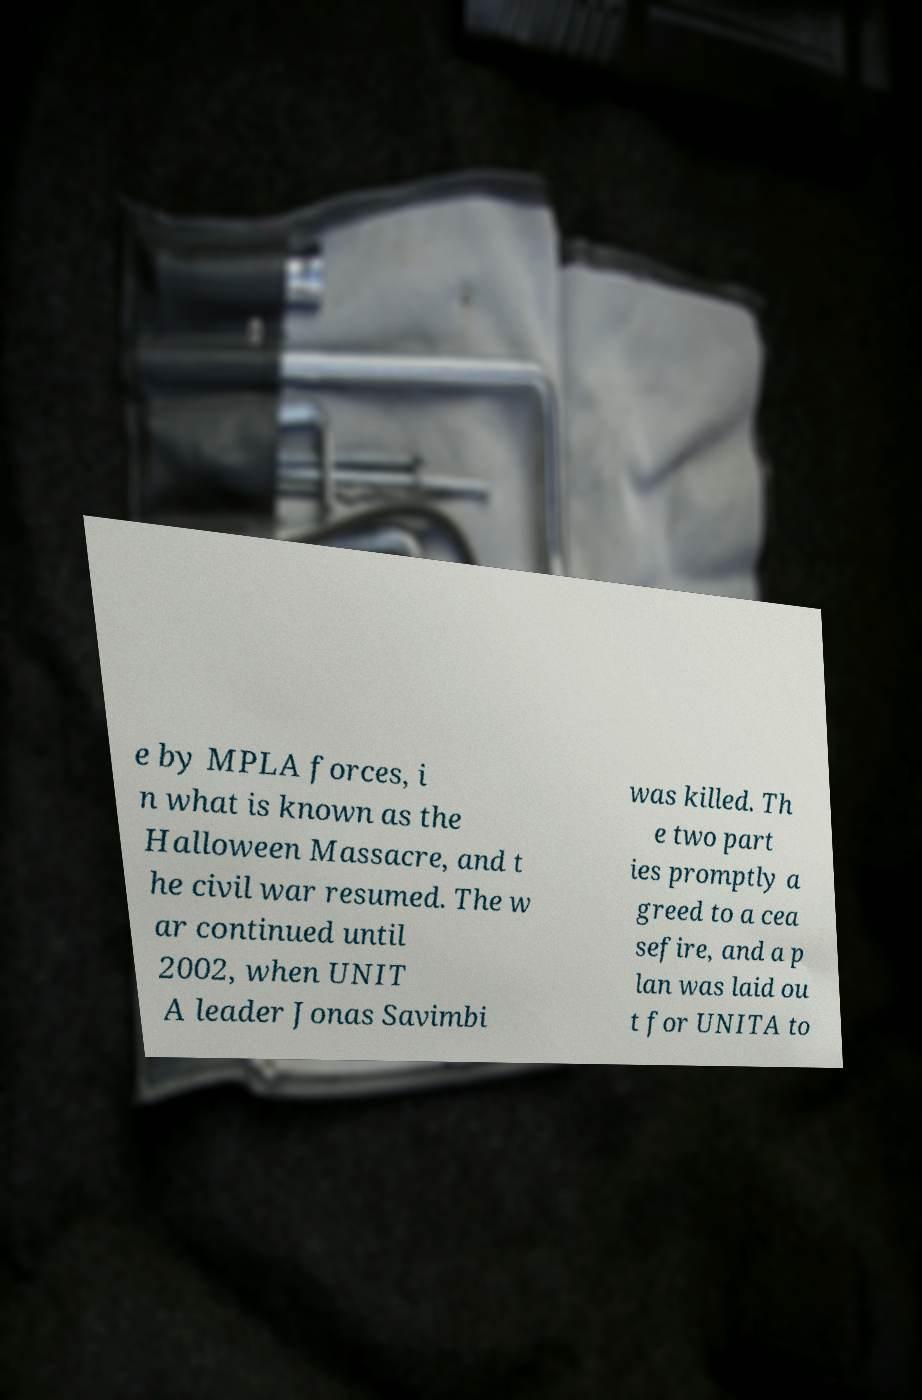Could you extract and type out the text from this image? e by MPLA forces, i n what is known as the Halloween Massacre, and t he civil war resumed. The w ar continued until 2002, when UNIT A leader Jonas Savimbi was killed. Th e two part ies promptly a greed to a cea sefire, and a p lan was laid ou t for UNITA to 